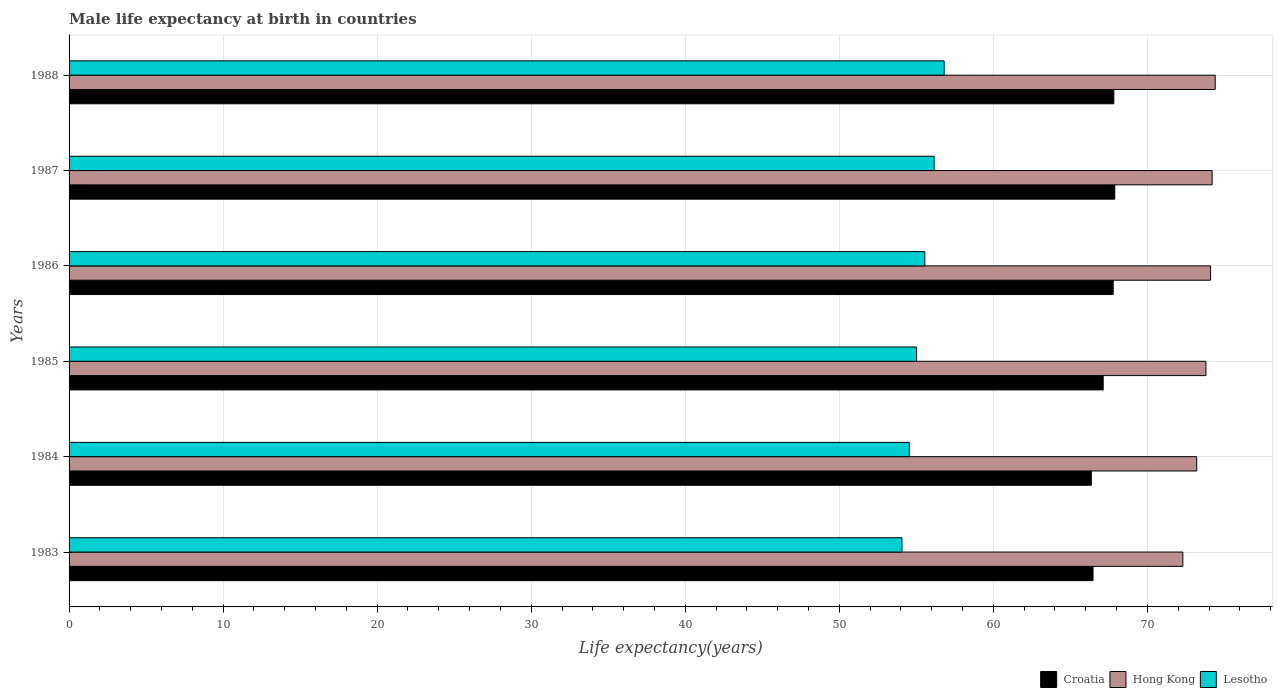How many different coloured bars are there?
Give a very brief answer. 3. How many groups of bars are there?
Offer a very short reply. 6. Are the number of bars per tick equal to the number of legend labels?
Ensure brevity in your answer.  Yes. Are the number of bars on each tick of the Y-axis equal?
Offer a very short reply. Yes. How many bars are there on the 1st tick from the top?
Your answer should be very brief. 3. In how many cases, is the number of bars for a given year not equal to the number of legend labels?
Your response must be concise. 0. What is the male life expectancy at birth in Lesotho in 1984?
Your answer should be very brief. 54.54. Across all years, what is the maximum male life expectancy at birth in Lesotho?
Your answer should be compact. 56.8. Across all years, what is the minimum male life expectancy at birth in Croatia?
Your response must be concise. 66.36. In which year was the male life expectancy at birth in Hong Kong maximum?
Provide a short and direct response. 1988. What is the total male life expectancy at birth in Lesotho in the graph?
Your answer should be very brief. 332.14. What is the difference between the male life expectancy at birth in Croatia in 1985 and that in 1987?
Provide a succinct answer. -0.75. What is the difference between the male life expectancy at birth in Hong Kong in 1988 and the male life expectancy at birth in Croatia in 1986?
Keep it short and to the point. 6.62. What is the average male life expectancy at birth in Hong Kong per year?
Make the answer very short. 73.67. In the year 1985, what is the difference between the male life expectancy at birth in Croatia and male life expectancy at birth in Lesotho?
Ensure brevity in your answer.  12.11. In how many years, is the male life expectancy at birth in Hong Kong greater than 62 years?
Give a very brief answer. 6. What is the ratio of the male life expectancy at birth in Hong Kong in 1983 to that in 1986?
Provide a succinct answer. 0.98. Is the male life expectancy at birth in Croatia in 1983 less than that in 1986?
Provide a succinct answer. Yes. What is the difference between the highest and the second highest male life expectancy at birth in Hong Kong?
Ensure brevity in your answer.  0.2. What is the difference between the highest and the lowest male life expectancy at birth in Croatia?
Provide a succinct answer. 1.52. In how many years, is the male life expectancy at birth in Hong Kong greater than the average male life expectancy at birth in Hong Kong taken over all years?
Keep it short and to the point. 4. What does the 3rd bar from the top in 1987 represents?
Ensure brevity in your answer.  Croatia. What does the 2nd bar from the bottom in 1985 represents?
Provide a succinct answer. Hong Kong. Is it the case that in every year, the sum of the male life expectancy at birth in Lesotho and male life expectancy at birth in Hong Kong is greater than the male life expectancy at birth in Croatia?
Ensure brevity in your answer.  Yes. Are all the bars in the graph horizontal?
Your answer should be compact. Yes. What is the difference between two consecutive major ticks on the X-axis?
Your answer should be compact. 10. What is the title of the graph?
Provide a short and direct response. Male life expectancy at birth in countries. What is the label or title of the X-axis?
Offer a terse response. Life expectancy(years). What is the label or title of the Y-axis?
Your response must be concise. Years. What is the Life expectancy(years) in Croatia in 1983?
Ensure brevity in your answer.  66.47. What is the Life expectancy(years) of Hong Kong in 1983?
Your answer should be compact. 72.3. What is the Life expectancy(years) in Lesotho in 1983?
Your response must be concise. 54.07. What is the Life expectancy(years) of Croatia in 1984?
Ensure brevity in your answer.  66.36. What is the Life expectancy(years) of Hong Kong in 1984?
Keep it short and to the point. 73.2. What is the Life expectancy(years) of Lesotho in 1984?
Provide a succinct answer. 54.54. What is the Life expectancy(years) of Croatia in 1985?
Offer a very short reply. 67.13. What is the Life expectancy(years) in Hong Kong in 1985?
Give a very brief answer. 73.8. What is the Life expectancy(years) of Lesotho in 1985?
Offer a terse response. 55.02. What is the Life expectancy(years) of Croatia in 1986?
Offer a very short reply. 67.78. What is the Life expectancy(years) of Hong Kong in 1986?
Make the answer very short. 74.1. What is the Life expectancy(years) of Lesotho in 1986?
Your answer should be very brief. 55.55. What is the Life expectancy(years) of Croatia in 1987?
Your answer should be very brief. 67.88. What is the Life expectancy(years) in Hong Kong in 1987?
Your response must be concise. 74.2. What is the Life expectancy(years) of Lesotho in 1987?
Ensure brevity in your answer.  56.15. What is the Life expectancy(years) in Croatia in 1988?
Provide a succinct answer. 67.82. What is the Life expectancy(years) in Hong Kong in 1988?
Offer a very short reply. 74.4. What is the Life expectancy(years) of Lesotho in 1988?
Ensure brevity in your answer.  56.8. Across all years, what is the maximum Life expectancy(years) in Croatia?
Provide a short and direct response. 67.88. Across all years, what is the maximum Life expectancy(years) in Hong Kong?
Give a very brief answer. 74.4. Across all years, what is the maximum Life expectancy(years) in Lesotho?
Make the answer very short. 56.8. Across all years, what is the minimum Life expectancy(years) in Croatia?
Provide a succinct answer. 66.36. Across all years, what is the minimum Life expectancy(years) of Hong Kong?
Offer a very short reply. 72.3. Across all years, what is the minimum Life expectancy(years) of Lesotho?
Provide a succinct answer. 54.07. What is the total Life expectancy(years) in Croatia in the graph?
Your answer should be very brief. 403.44. What is the total Life expectancy(years) of Hong Kong in the graph?
Offer a very short reply. 442. What is the total Life expectancy(years) of Lesotho in the graph?
Offer a terse response. 332.14. What is the difference between the Life expectancy(years) of Croatia in 1983 and that in 1984?
Give a very brief answer. 0.11. What is the difference between the Life expectancy(years) of Lesotho in 1983 and that in 1984?
Offer a very short reply. -0.48. What is the difference between the Life expectancy(years) of Croatia in 1983 and that in 1985?
Provide a succinct answer. -0.66. What is the difference between the Life expectancy(years) in Lesotho in 1983 and that in 1985?
Ensure brevity in your answer.  -0.95. What is the difference between the Life expectancy(years) of Croatia in 1983 and that in 1986?
Offer a very short reply. -1.31. What is the difference between the Life expectancy(years) of Lesotho in 1983 and that in 1986?
Keep it short and to the point. -1.49. What is the difference between the Life expectancy(years) in Croatia in 1983 and that in 1987?
Offer a terse response. -1.41. What is the difference between the Life expectancy(years) of Hong Kong in 1983 and that in 1987?
Provide a short and direct response. -1.9. What is the difference between the Life expectancy(years) in Lesotho in 1983 and that in 1987?
Give a very brief answer. -2.09. What is the difference between the Life expectancy(years) of Croatia in 1983 and that in 1988?
Provide a short and direct response. -1.35. What is the difference between the Life expectancy(years) in Lesotho in 1983 and that in 1988?
Offer a terse response. -2.74. What is the difference between the Life expectancy(years) of Croatia in 1984 and that in 1985?
Your response must be concise. -0.77. What is the difference between the Life expectancy(years) in Hong Kong in 1984 and that in 1985?
Your answer should be very brief. -0.6. What is the difference between the Life expectancy(years) in Lesotho in 1984 and that in 1985?
Your response must be concise. -0.48. What is the difference between the Life expectancy(years) of Croatia in 1984 and that in 1986?
Keep it short and to the point. -1.42. What is the difference between the Life expectancy(years) in Hong Kong in 1984 and that in 1986?
Your response must be concise. -0.9. What is the difference between the Life expectancy(years) of Lesotho in 1984 and that in 1986?
Make the answer very short. -1.01. What is the difference between the Life expectancy(years) of Croatia in 1984 and that in 1987?
Keep it short and to the point. -1.52. What is the difference between the Life expectancy(years) in Hong Kong in 1984 and that in 1987?
Your answer should be very brief. -1. What is the difference between the Life expectancy(years) in Lesotho in 1984 and that in 1987?
Keep it short and to the point. -1.61. What is the difference between the Life expectancy(years) in Croatia in 1984 and that in 1988?
Your answer should be very brief. -1.46. What is the difference between the Life expectancy(years) in Hong Kong in 1984 and that in 1988?
Keep it short and to the point. -1.2. What is the difference between the Life expectancy(years) of Lesotho in 1984 and that in 1988?
Give a very brief answer. -2.26. What is the difference between the Life expectancy(years) in Croatia in 1985 and that in 1986?
Ensure brevity in your answer.  -0.65. What is the difference between the Life expectancy(years) in Lesotho in 1985 and that in 1986?
Make the answer very short. -0.53. What is the difference between the Life expectancy(years) of Croatia in 1985 and that in 1987?
Your response must be concise. -0.75. What is the difference between the Life expectancy(years) in Hong Kong in 1985 and that in 1987?
Give a very brief answer. -0.4. What is the difference between the Life expectancy(years) of Lesotho in 1985 and that in 1987?
Keep it short and to the point. -1.14. What is the difference between the Life expectancy(years) in Croatia in 1985 and that in 1988?
Provide a short and direct response. -0.69. What is the difference between the Life expectancy(years) of Lesotho in 1985 and that in 1988?
Provide a short and direct response. -1.79. What is the difference between the Life expectancy(years) in Croatia in 1986 and that in 1987?
Keep it short and to the point. -0.1. What is the difference between the Life expectancy(years) of Lesotho in 1986 and that in 1987?
Your response must be concise. -0.6. What is the difference between the Life expectancy(years) in Croatia in 1986 and that in 1988?
Offer a very short reply. -0.04. What is the difference between the Life expectancy(years) in Hong Kong in 1986 and that in 1988?
Your response must be concise. -0.3. What is the difference between the Life expectancy(years) in Lesotho in 1986 and that in 1988?
Make the answer very short. -1.25. What is the difference between the Life expectancy(years) in Hong Kong in 1987 and that in 1988?
Ensure brevity in your answer.  -0.2. What is the difference between the Life expectancy(years) of Lesotho in 1987 and that in 1988?
Ensure brevity in your answer.  -0.65. What is the difference between the Life expectancy(years) in Croatia in 1983 and the Life expectancy(years) in Hong Kong in 1984?
Make the answer very short. -6.73. What is the difference between the Life expectancy(years) of Croatia in 1983 and the Life expectancy(years) of Lesotho in 1984?
Your answer should be very brief. 11.93. What is the difference between the Life expectancy(years) in Hong Kong in 1983 and the Life expectancy(years) in Lesotho in 1984?
Provide a succinct answer. 17.76. What is the difference between the Life expectancy(years) in Croatia in 1983 and the Life expectancy(years) in Hong Kong in 1985?
Give a very brief answer. -7.33. What is the difference between the Life expectancy(years) in Croatia in 1983 and the Life expectancy(years) in Lesotho in 1985?
Offer a very short reply. 11.45. What is the difference between the Life expectancy(years) of Hong Kong in 1983 and the Life expectancy(years) of Lesotho in 1985?
Give a very brief answer. 17.28. What is the difference between the Life expectancy(years) of Croatia in 1983 and the Life expectancy(years) of Hong Kong in 1986?
Give a very brief answer. -7.63. What is the difference between the Life expectancy(years) in Croatia in 1983 and the Life expectancy(years) in Lesotho in 1986?
Provide a succinct answer. 10.92. What is the difference between the Life expectancy(years) in Hong Kong in 1983 and the Life expectancy(years) in Lesotho in 1986?
Give a very brief answer. 16.75. What is the difference between the Life expectancy(years) in Croatia in 1983 and the Life expectancy(years) in Hong Kong in 1987?
Offer a very short reply. -7.73. What is the difference between the Life expectancy(years) in Croatia in 1983 and the Life expectancy(years) in Lesotho in 1987?
Your answer should be very brief. 10.32. What is the difference between the Life expectancy(years) of Hong Kong in 1983 and the Life expectancy(years) of Lesotho in 1987?
Provide a short and direct response. 16.15. What is the difference between the Life expectancy(years) of Croatia in 1983 and the Life expectancy(years) of Hong Kong in 1988?
Give a very brief answer. -7.93. What is the difference between the Life expectancy(years) of Croatia in 1983 and the Life expectancy(years) of Lesotho in 1988?
Your answer should be very brief. 9.66. What is the difference between the Life expectancy(years) in Hong Kong in 1983 and the Life expectancy(years) in Lesotho in 1988?
Your response must be concise. 15.49. What is the difference between the Life expectancy(years) in Croatia in 1984 and the Life expectancy(years) in Hong Kong in 1985?
Your response must be concise. -7.44. What is the difference between the Life expectancy(years) of Croatia in 1984 and the Life expectancy(years) of Lesotho in 1985?
Provide a short and direct response. 11.34. What is the difference between the Life expectancy(years) in Hong Kong in 1984 and the Life expectancy(years) in Lesotho in 1985?
Give a very brief answer. 18.18. What is the difference between the Life expectancy(years) in Croatia in 1984 and the Life expectancy(years) in Hong Kong in 1986?
Ensure brevity in your answer.  -7.74. What is the difference between the Life expectancy(years) of Croatia in 1984 and the Life expectancy(years) of Lesotho in 1986?
Your answer should be very brief. 10.81. What is the difference between the Life expectancy(years) of Hong Kong in 1984 and the Life expectancy(years) of Lesotho in 1986?
Your answer should be compact. 17.65. What is the difference between the Life expectancy(years) of Croatia in 1984 and the Life expectancy(years) of Hong Kong in 1987?
Ensure brevity in your answer.  -7.84. What is the difference between the Life expectancy(years) of Croatia in 1984 and the Life expectancy(years) of Lesotho in 1987?
Ensure brevity in your answer.  10.21. What is the difference between the Life expectancy(years) in Hong Kong in 1984 and the Life expectancy(years) in Lesotho in 1987?
Your answer should be very brief. 17.05. What is the difference between the Life expectancy(years) of Croatia in 1984 and the Life expectancy(years) of Hong Kong in 1988?
Offer a very short reply. -8.04. What is the difference between the Life expectancy(years) in Croatia in 1984 and the Life expectancy(years) in Lesotho in 1988?
Make the answer very short. 9.55. What is the difference between the Life expectancy(years) in Hong Kong in 1984 and the Life expectancy(years) in Lesotho in 1988?
Give a very brief answer. 16.39. What is the difference between the Life expectancy(years) in Croatia in 1985 and the Life expectancy(years) in Hong Kong in 1986?
Offer a very short reply. -6.97. What is the difference between the Life expectancy(years) in Croatia in 1985 and the Life expectancy(years) in Lesotho in 1986?
Offer a terse response. 11.58. What is the difference between the Life expectancy(years) in Hong Kong in 1985 and the Life expectancy(years) in Lesotho in 1986?
Make the answer very short. 18.25. What is the difference between the Life expectancy(years) of Croatia in 1985 and the Life expectancy(years) of Hong Kong in 1987?
Your response must be concise. -7.07. What is the difference between the Life expectancy(years) of Croatia in 1985 and the Life expectancy(years) of Lesotho in 1987?
Give a very brief answer. 10.98. What is the difference between the Life expectancy(years) of Hong Kong in 1985 and the Life expectancy(years) of Lesotho in 1987?
Keep it short and to the point. 17.65. What is the difference between the Life expectancy(years) in Croatia in 1985 and the Life expectancy(years) in Hong Kong in 1988?
Keep it short and to the point. -7.27. What is the difference between the Life expectancy(years) of Croatia in 1985 and the Life expectancy(years) of Lesotho in 1988?
Your answer should be very brief. 10.32. What is the difference between the Life expectancy(years) of Hong Kong in 1985 and the Life expectancy(years) of Lesotho in 1988?
Your response must be concise. 17. What is the difference between the Life expectancy(years) of Croatia in 1986 and the Life expectancy(years) of Hong Kong in 1987?
Offer a very short reply. -6.42. What is the difference between the Life expectancy(years) in Croatia in 1986 and the Life expectancy(years) in Lesotho in 1987?
Provide a succinct answer. 11.63. What is the difference between the Life expectancy(years) in Hong Kong in 1986 and the Life expectancy(years) in Lesotho in 1987?
Your response must be concise. 17.95. What is the difference between the Life expectancy(years) of Croatia in 1986 and the Life expectancy(years) of Hong Kong in 1988?
Ensure brevity in your answer.  -6.62. What is the difference between the Life expectancy(years) of Croatia in 1986 and the Life expectancy(years) of Lesotho in 1988?
Keep it short and to the point. 10.97. What is the difference between the Life expectancy(years) in Hong Kong in 1986 and the Life expectancy(years) in Lesotho in 1988?
Your response must be concise. 17.3. What is the difference between the Life expectancy(years) in Croatia in 1987 and the Life expectancy(years) in Hong Kong in 1988?
Keep it short and to the point. -6.52. What is the difference between the Life expectancy(years) in Croatia in 1987 and the Life expectancy(years) in Lesotho in 1988?
Your answer should be compact. 11.07. What is the difference between the Life expectancy(years) of Hong Kong in 1987 and the Life expectancy(years) of Lesotho in 1988?
Keep it short and to the point. 17.39. What is the average Life expectancy(years) of Croatia per year?
Your answer should be compact. 67.24. What is the average Life expectancy(years) of Hong Kong per year?
Offer a very short reply. 73.67. What is the average Life expectancy(years) of Lesotho per year?
Provide a short and direct response. 55.36. In the year 1983, what is the difference between the Life expectancy(years) in Croatia and Life expectancy(years) in Hong Kong?
Offer a terse response. -5.83. In the year 1983, what is the difference between the Life expectancy(years) of Croatia and Life expectancy(years) of Lesotho?
Provide a short and direct response. 12.4. In the year 1983, what is the difference between the Life expectancy(years) of Hong Kong and Life expectancy(years) of Lesotho?
Offer a very short reply. 18.23. In the year 1984, what is the difference between the Life expectancy(years) in Croatia and Life expectancy(years) in Hong Kong?
Ensure brevity in your answer.  -6.84. In the year 1984, what is the difference between the Life expectancy(years) of Croatia and Life expectancy(years) of Lesotho?
Your answer should be compact. 11.82. In the year 1984, what is the difference between the Life expectancy(years) in Hong Kong and Life expectancy(years) in Lesotho?
Your answer should be very brief. 18.66. In the year 1985, what is the difference between the Life expectancy(years) in Croatia and Life expectancy(years) in Hong Kong?
Offer a very short reply. -6.67. In the year 1985, what is the difference between the Life expectancy(years) in Croatia and Life expectancy(years) in Lesotho?
Make the answer very short. 12.11. In the year 1985, what is the difference between the Life expectancy(years) of Hong Kong and Life expectancy(years) of Lesotho?
Make the answer very short. 18.78. In the year 1986, what is the difference between the Life expectancy(years) in Croatia and Life expectancy(years) in Hong Kong?
Provide a succinct answer. -6.32. In the year 1986, what is the difference between the Life expectancy(years) of Croatia and Life expectancy(years) of Lesotho?
Ensure brevity in your answer.  12.23. In the year 1986, what is the difference between the Life expectancy(years) of Hong Kong and Life expectancy(years) of Lesotho?
Offer a terse response. 18.55. In the year 1987, what is the difference between the Life expectancy(years) in Croatia and Life expectancy(years) in Hong Kong?
Keep it short and to the point. -6.32. In the year 1987, what is the difference between the Life expectancy(years) in Croatia and Life expectancy(years) in Lesotho?
Ensure brevity in your answer.  11.73. In the year 1987, what is the difference between the Life expectancy(years) in Hong Kong and Life expectancy(years) in Lesotho?
Offer a very short reply. 18.05. In the year 1988, what is the difference between the Life expectancy(years) in Croatia and Life expectancy(years) in Hong Kong?
Ensure brevity in your answer.  -6.58. In the year 1988, what is the difference between the Life expectancy(years) of Croatia and Life expectancy(years) of Lesotho?
Offer a terse response. 11.02. In the year 1988, what is the difference between the Life expectancy(years) in Hong Kong and Life expectancy(years) in Lesotho?
Offer a terse response. 17.59. What is the ratio of the Life expectancy(years) of Croatia in 1983 to that in 1984?
Provide a succinct answer. 1. What is the ratio of the Life expectancy(years) of Hong Kong in 1983 to that in 1984?
Your answer should be compact. 0.99. What is the ratio of the Life expectancy(years) of Lesotho in 1983 to that in 1984?
Your answer should be very brief. 0.99. What is the ratio of the Life expectancy(years) in Croatia in 1983 to that in 1985?
Ensure brevity in your answer.  0.99. What is the ratio of the Life expectancy(years) of Hong Kong in 1983 to that in 1985?
Make the answer very short. 0.98. What is the ratio of the Life expectancy(years) of Lesotho in 1983 to that in 1985?
Offer a terse response. 0.98. What is the ratio of the Life expectancy(years) of Croatia in 1983 to that in 1986?
Provide a short and direct response. 0.98. What is the ratio of the Life expectancy(years) in Hong Kong in 1983 to that in 1986?
Provide a succinct answer. 0.98. What is the ratio of the Life expectancy(years) in Lesotho in 1983 to that in 1986?
Give a very brief answer. 0.97. What is the ratio of the Life expectancy(years) in Croatia in 1983 to that in 1987?
Provide a succinct answer. 0.98. What is the ratio of the Life expectancy(years) of Hong Kong in 1983 to that in 1987?
Keep it short and to the point. 0.97. What is the ratio of the Life expectancy(years) in Lesotho in 1983 to that in 1987?
Ensure brevity in your answer.  0.96. What is the ratio of the Life expectancy(years) in Croatia in 1983 to that in 1988?
Your response must be concise. 0.98. What is the ratio of the Life expectancy(years) of Hong Kong in 1983 to that in 1988?
Offer a very short reply. 0.97. What is the ratio of the Life expectancy(years) in Lesotho in 1983 to that in 1988?
Give a very brief answer. 0.95. What is the ratio of the Life expectancy(years) of Hong Kong in 1984 to that in 1985?
Provide a succinct answer. 0.99. What is the ratio of the Life expectancy(years) in Croatia in 1984 to that in 1986?
Give a very brief answer. 0.98. What is the ratio of the Life expectancy(years) in Hong Kong in 1984 to that in 1986?
Your answer should be very brief. 0.99. What is the ratio of the Life expectancy(years) of Lesotho in 1984 to that in 1986?
Provide a short and direct response. 0.98. What is the ratio of the Life expectancy(years) of Croatia in 1984 to that in 1987?
Provide a succinct answer. 0.98. What is the ratio of the Life expectancy(years) of Hong Kong in 1984 to that in 1987?
Keep it short and to the point. 0.99. What is the ratio of the Life expectancy(years) of Lesotho in 1984 to that in 1987?
Provide a short and direct response. 0.97. What is the ratio of the Life expectancy(years) of Croatia in 1984 to that in 1988?
Offer a terse response. 0.98. What is the ratio of the Life expectancy(years) of Hong Kong in 1984 to that in 1988?
Provide a succinct answer. 0.98. What is the ratio of the Life expectancy(years) in Lesotho in 1984 to that in 1988?
Give a very brief answer. 0.96. What is the ratio of the Life expectancy(years) of Croatia in 1985 to that in 1986?
Your answer should be very brief. 0.99. What is the ratio of the Life expectancy(years) in Croatia in 1985 to that in 1987?
Make the answer very short. 0.99. What is the ratio of the Life expectancy(years) of Hong Kong in 1985 to that in 1987?
Make the answer very short. 0.99. What is the ratio of the Life expectancy(years) in Lesotho in 1985 to that in 1987?
Keep it short and to the point. 0.98. What is the ratio of the Life expectancy(years) in Lesotho in 1985 to that in 1988?
Make the answer very short. 0.97. What is the ratio of the Life expectancy(years) of Lesotho in 1986 to that in 1987?
Your answer should be compact. 0.99. What is the ratio of the Life expectancy(years) of Hong Kong in 1986 to that in 1988?
Your response must be concise. 1. What is the ratio of the Life expectancy(years) in Lesotho in 1986 to that in 1988?
Offer a terse response. 0.98. What is the ratio of the Life expectancy(years) in Croatia in 1987 to that in 1988?
Give a very brief answer. 1. What is the ratio of the Life expectancy(years) of Hong Kong in 1987 to that in 1988?
Offer a terse response. 1. What is the difference between the highest and the second highest Life expectancy(years) in Croatia?
Provide a succinct answer. 0.06. What is the difference between the highest and the second highest Life expectancy(years) in Hong Kong?
Make the answer very short. 0.2. What is the difference between the highest and the second highest Life expectancy(years) in Lesotho?
Provide a short and direct response. 0.65. What is the difference between the highest and the lowest Life expectancy(years) of Croatia?
Your answer should be compact. 1.52. What is the difference between the highest and the lowest Life expectancy(years) in Hong Kong?
Your answer should be very brief. 2.1. What is the difference between the highest and the lowest Life expectancy(years) of Lesotho?
Offer a very short reply. 2.74. 